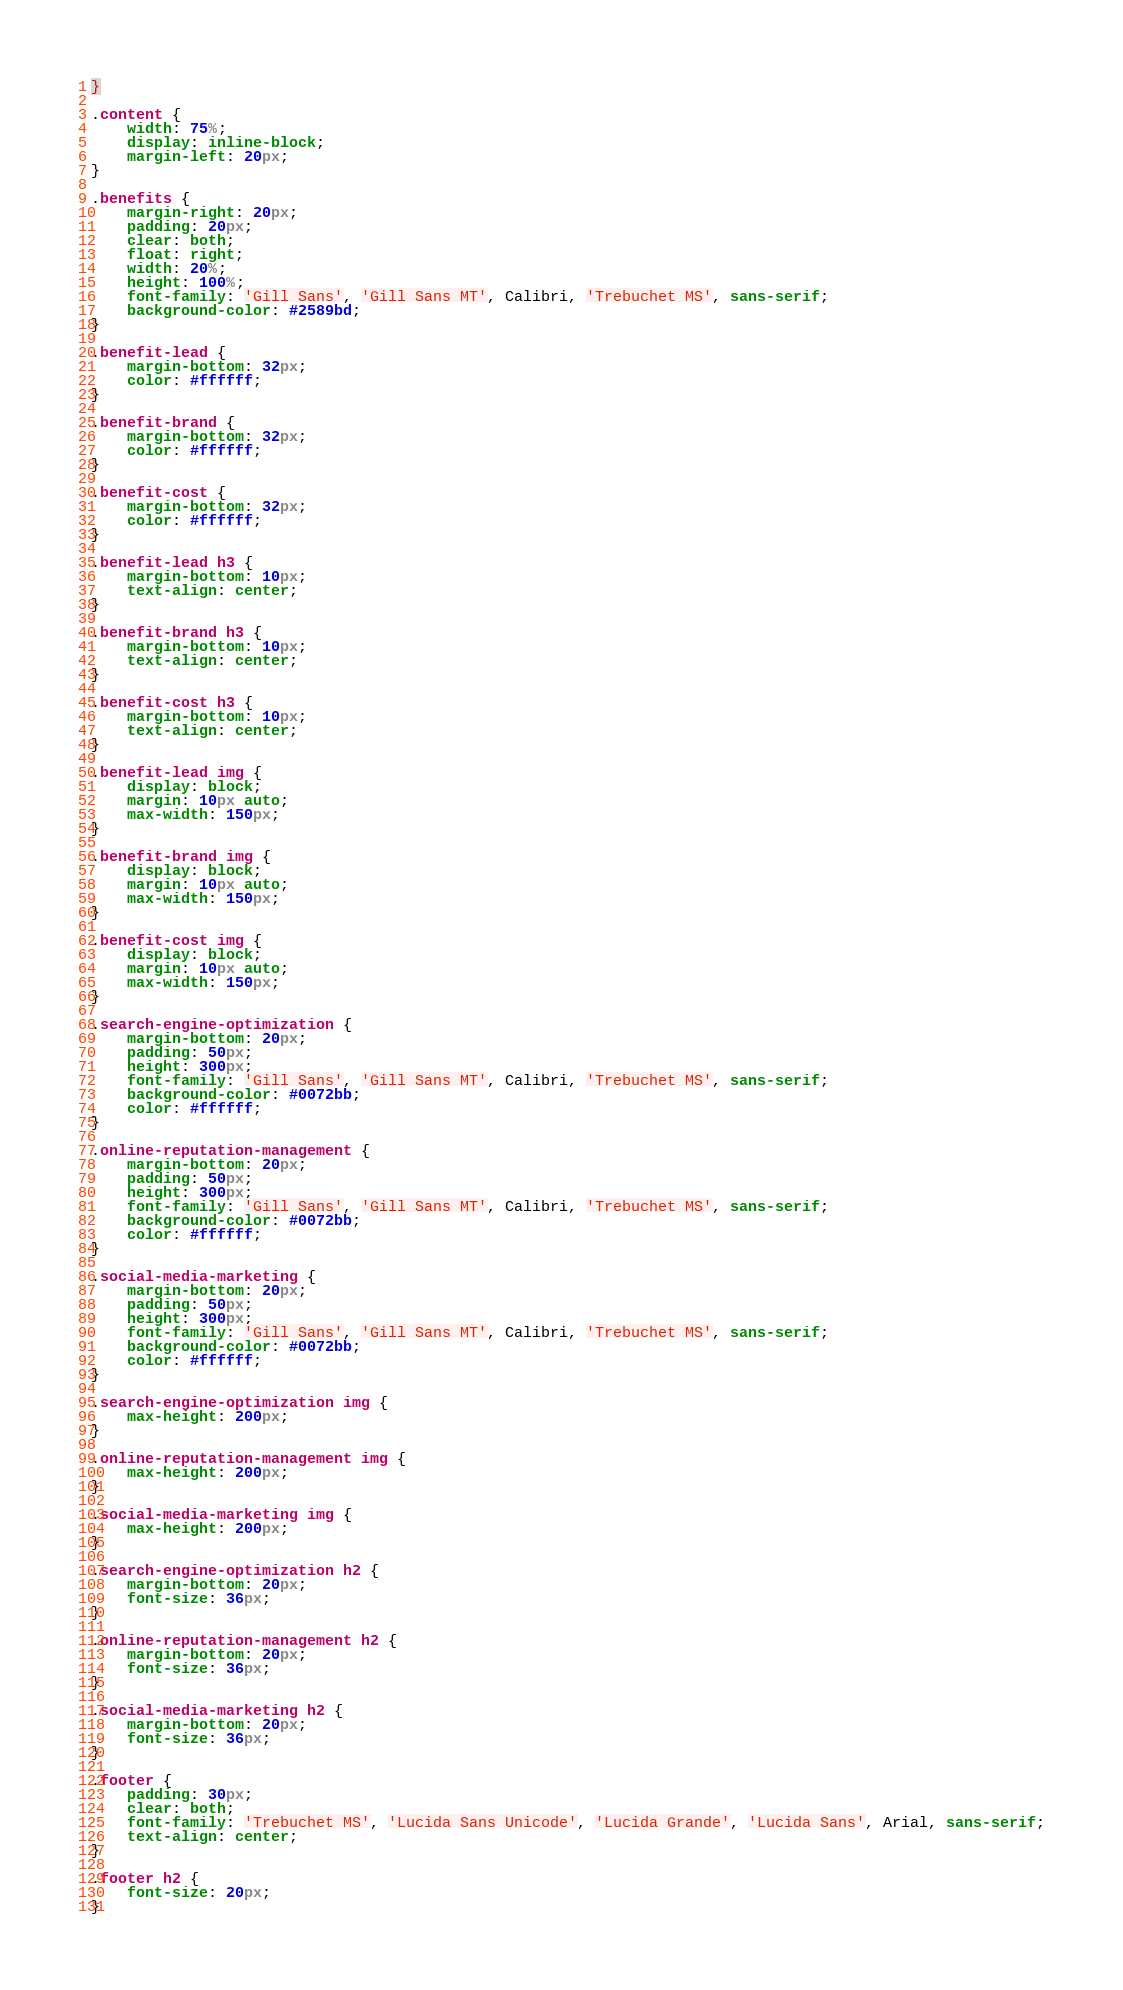Convert code to text. <code><loc_0><loc_0><loc_500><loc_500><_CSS_>}

.content {
    width: 75%;
    display: inline-block;
    margin-left: 20px;
}

.benefits {
    margin-right: 20px;
    padding: 20px;
    clear: both;
    float: right;
    width: 20%;
    height: 100%;
    font-family: 'Gill Sans', 'Gill Sans MT', Calibri, 'Trebuchet MS', sans-serif;
    background-color: #2589bd;
}

.benefit-lead {
    margin-bottom: 32px;
    color: #ffffff;
}

.benefit-brand {
    margin-bottom: 32px;
    color: #ffffff;
}

.benefit-cost {
    margin-bottom: 32px;
    color: #ffffff;
}

.benefit-lead h3 {
    margin-bottom: 10px;
    text-align: center;
}

.benefit-brand h3 {
    margin-bottom: 10px;
    text-align: center;
}

.benefit-cost h3 {
    margin-bottom: 10px;
    text-align: center;
}

.benefit-lead img {
    display: block;
    margin: 10px auto;
    max-width: 150px;
}

.benefit-brand img {
    display: block;
    margin: 10px auto;
    max-width: 150px;
}

.benefit-cost img {
    display: block;
    margin: 10px auto;
    max-width: 150px;
}

.search-engine-optimization {
    margin-bottom: 20px;
    padding: 50px;
    height: 300px;
    font-family: 'Gill Sans', 'Gill Sans MT', Calibri, 'Trebuchet MS', sans-serif;
    background-color: #0072bb;
    color: #ffffff;
}

.online-reputation-management {
    margin-bottom: 20px;
    padding: 50px;
    height: 300px;
    font-family: 'Gill Sans', 'Gill Sans MT', Calibri, 'Trebuchet MS', sans-serif;
    background-color: #0072bb;
    color: #ffffff;
}

.social-media-marketing {
    margin-bottom: 20px;
    padding: 50px;
    height: 300px;
    font-family: 'Gill Sans', 'Gill Sans MT', Calibri, 'Trebuchet MS', sans-serif;
    background-color: #0072bb;
    color: #ffffff;
}

.search-engine-optimization img {
    max-height: 200px;
}

.online-reputation-management img {
    max-height: 200px;
}

.social-media-marketing img {
    max-height: 200px;
}

.search-engine-optimization h2 {
    margin-bottom: 20px;
    font-size: 36px;
}

.online-reputation-management h2 {
    margin-bottom: 20px;
    font-size: 36px;
}

.social-media-marketing h2 {
    margin-bottom: 20px;
    font-size: 36px;
}

.footer {
    padding: 30px;
    clear: both;
    font-family: 'Trebuchet MS', 'Lucida Sans Unicode', 'Lucida Grande', 'Lucida Sans', Arial, sans-serif;
    text-align: center;
}

.footer h2 {
    font-size: 20px;
}


</code> 